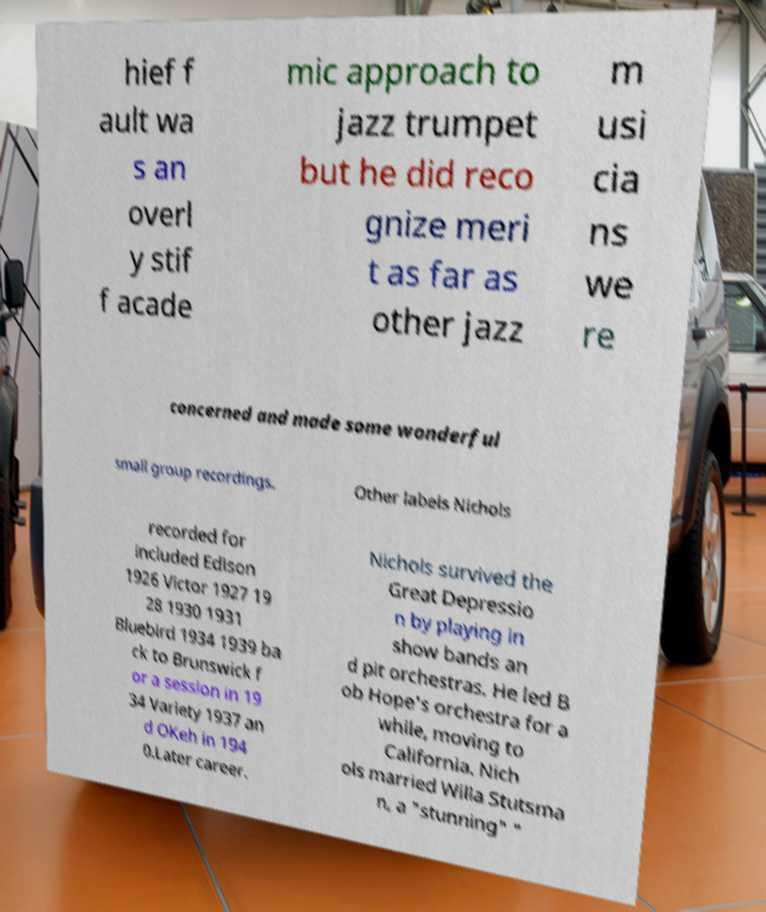Could you assist in decoding the text presented in this image and type it out clearly? hief f ault wa s an overl y stif f acade mic approach to jazz trumpet but he did reco gnize meri t as far as other jazz m usi cia ns we re concerned and made some wonderful small group recordings. Other labels Nichols recorded for included Edison 1926 Victor 1927 19 28 1930 1931 Bluebird 1934 1939 ba ck to Brunswick f or a session in 19 34 Variety 1937 an d OKeh in 194 0.Later career. Nichols survived the Great Depressio n by playing in show bands an d pit orchestras. He led B ob Hope's orchestra for a while, moving to California. Nich ols married Willa Stutsma n, a "stunning" " 